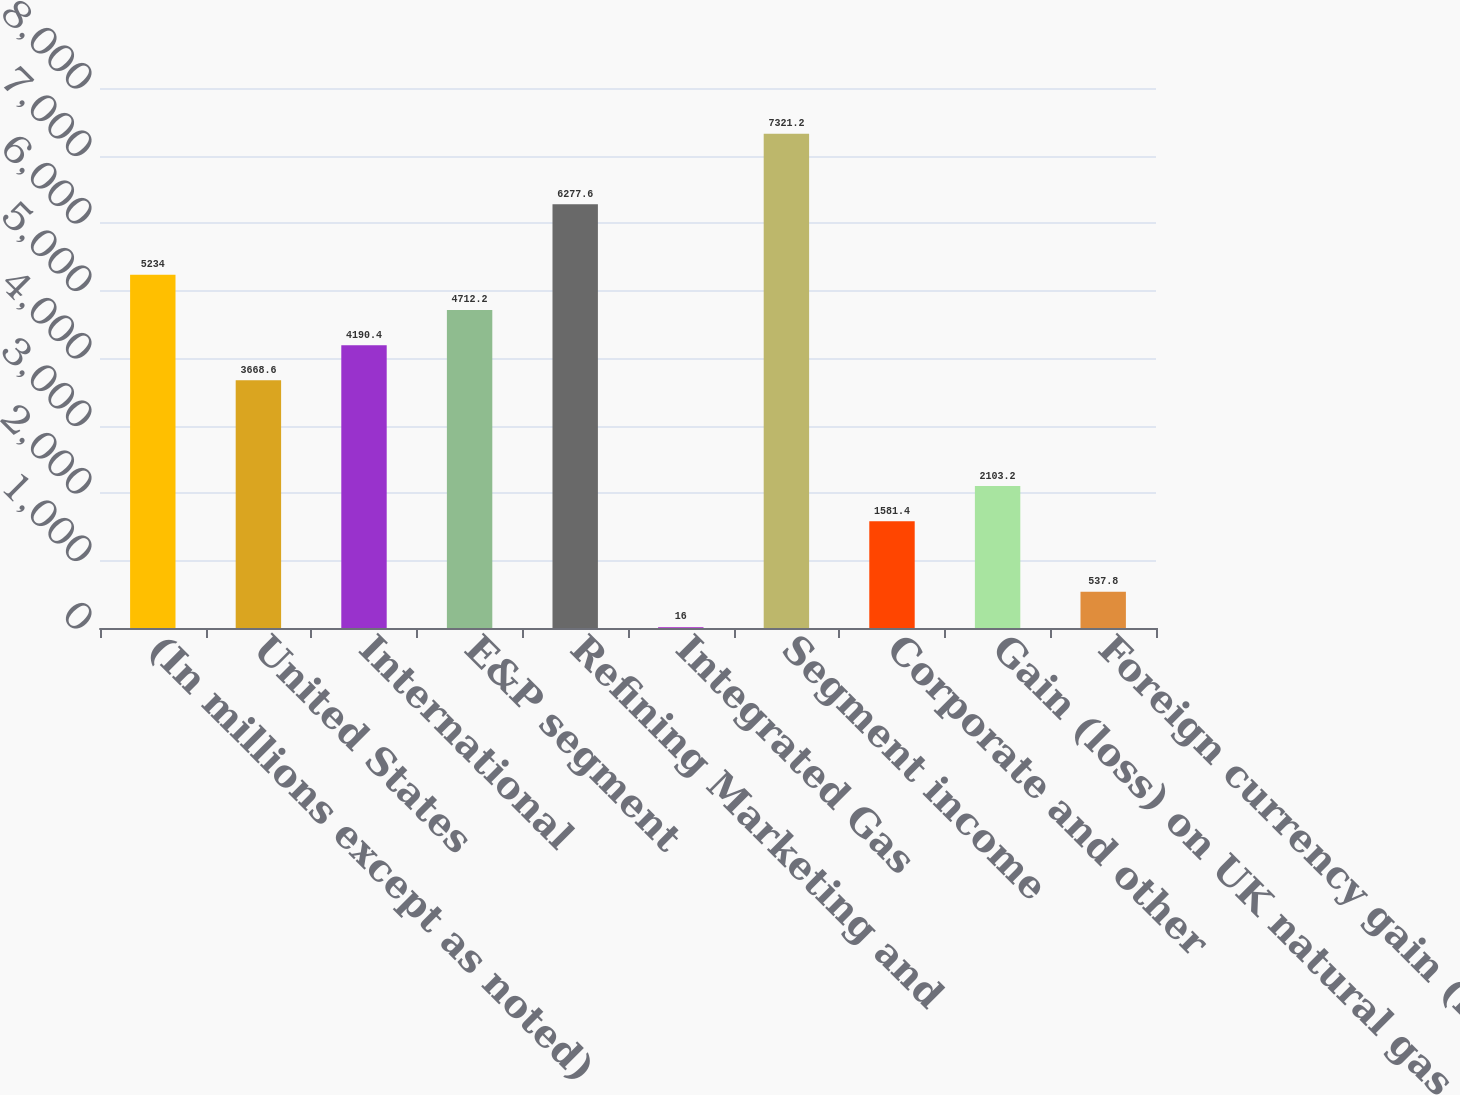<chart> <loc_0><loc_0><loc_500><loc_500><bar_chart><fcel>(In millions except as noted)<fcel>United States<fcel>International<fcel>E&P segment<fcel>Refining Marketing and<fcel>Integrated Gas<fcel>Segment income<fcel>Corporate and other<fcel>Gain (loss) on UK natural gas<fcel>Foreign currency gain (loss)<nl><fcel>5234<fcel>3668.6<fcel>4190.4<fcel>4712.2<fcel>6277.6<fcel>16<fcel>7321.2<fcel>1581.4<fcel>2103.2<fcel>537.8<nl></chart> 